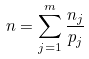Convert formula to latex. <formula><loc_0><loc_0><loc_500><loc_500>n = \sum _ { j = 1 } ^ { m } \frac { n _ { j } } { p _ { j } }</formula> 